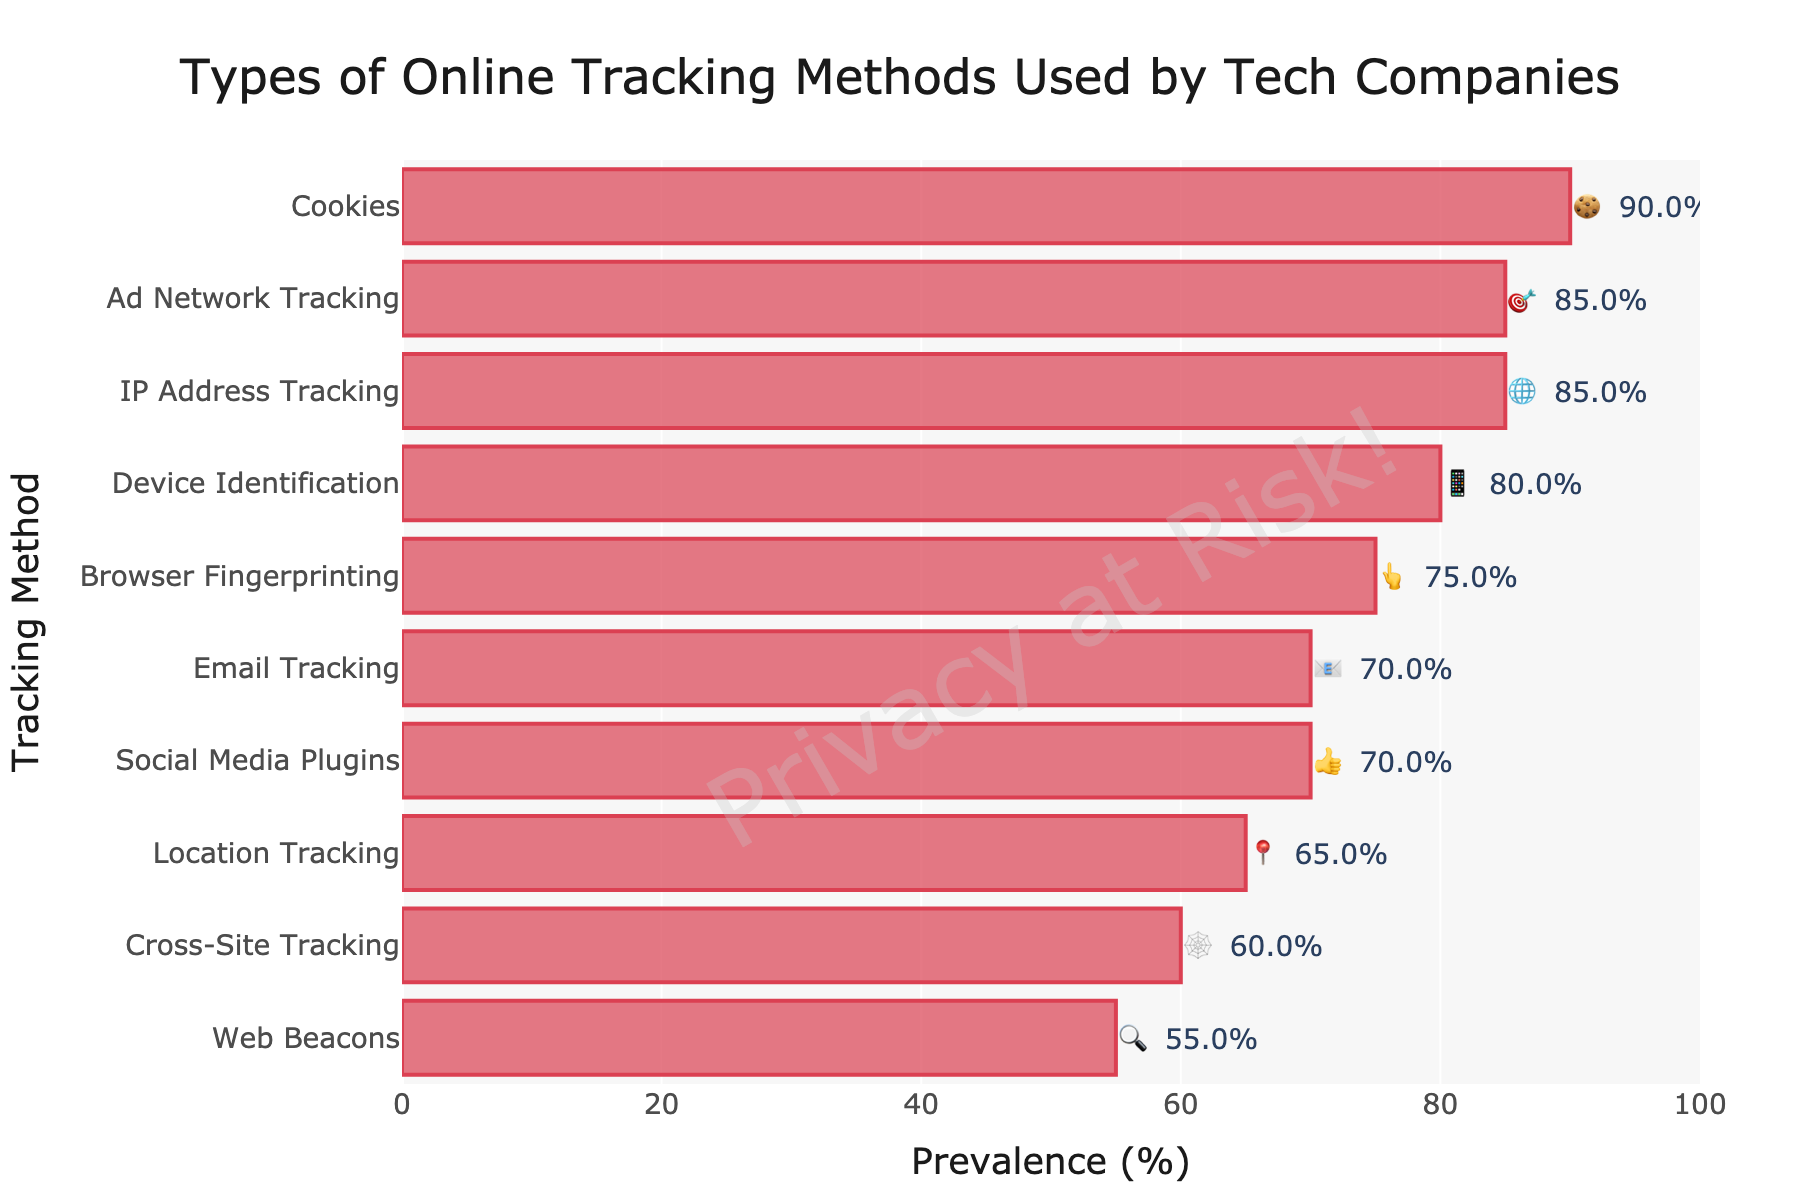What is the most prevalent tracking method according to the chart? The chart lists the tracking methods with their corresponding prevalence. Cookies have the highest prevalence at 90%.
Answer: Cookies Which tracking methods have the same prevalence percentage? By checking the prevalence values, IP Address Tracking and Ad Network Tracking both have a prevalence of 85%, and Social Media Plugins and Email Tracking both have a prevalence of 70%.
Answer: IP Address Tracking and Ad Network Tracking; Social Media Plugins and Email Tracking How many tracking methods have a prevalence percentage of 75% or higher? We count the tracking methods with prevalence percentages 75% or higher. They are Cookies, Browser Fingerprinting, IP Address Tracking, Device Identification, and Ad Network Tracking, totaling 5 methods.
Answer: 5 What is the difference in prevalence between Cookies and Cross-Site Tracking? Cookies have a prevalence of 90%, and Cross-Site Tracking has 60%. The difference is 90% - 60% = 30%.
Answer: 30% Which tracking method is represented by the 📱 emoji, and what is its prevalence? The 📱 emoji represents Device Identification, which has a prevalence of 80%.
Answer: Device Identification, 80% What tracking methods have a prevalence between 50% and 60%? The chart shows that Web Beacons have a prevalence of 55%, which falls between 50% and 60%.
Answer: Web Beacons Compare the prevalence of Browser Fingerprinting and Location Tracking. Which one is more common? Browser Fingerprinting has a prevalence of 75%, while Location Tracking has 65%. Browser Fingerprinting is more common.
Answer: Browser Fingerprinting What is the total prevalence percentage of the four least common tracking methods? The four least common methods are Web Beacons (55%), Cross-Site Tracking (60%), Location Tracking (65%), and Social Media Plugins (70%). Total prevalence = 55% + 60% + 65% + 70% = 250%.
Answer: 250% Identify two tracking methods with the closest prevalence percentages and state their values. The two tracking methods with the closest prevalence are Social Media Plugins (70%) and Email Tracking (70%).
Answer: Social Media Plugins and Email Tracking, 70% 